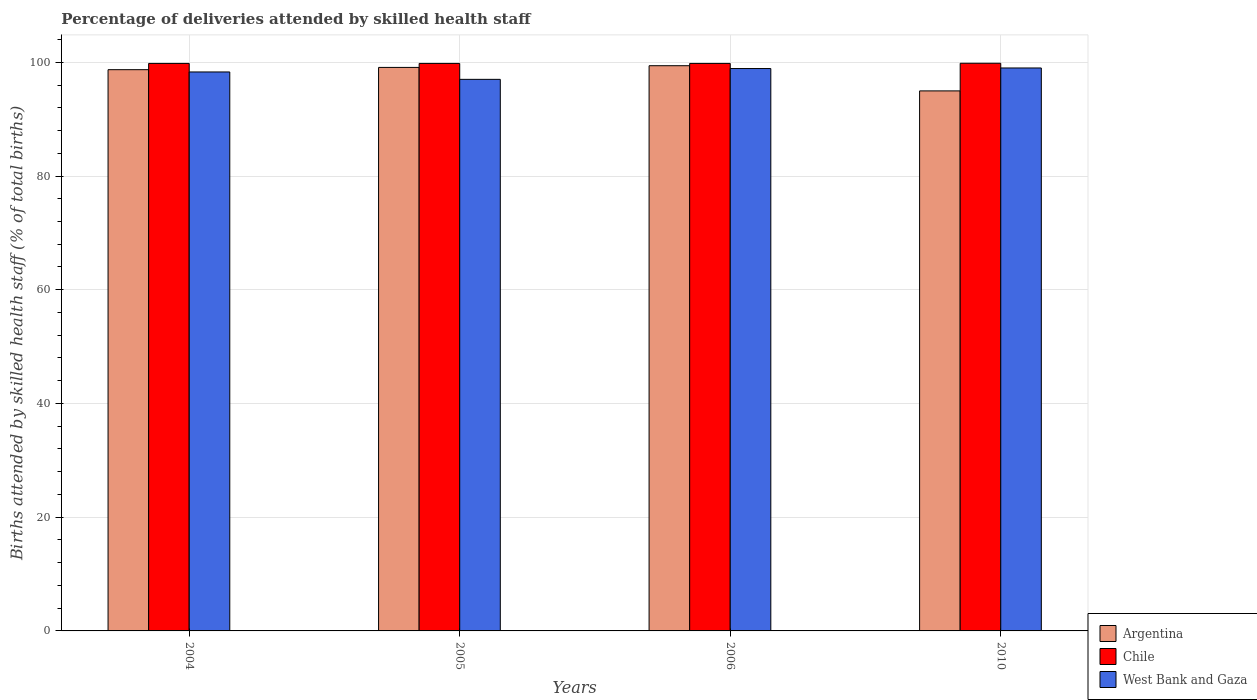How many groups of bars are there?
Your response must be concise. 4. Are the number of bars per tick equal to the number of legend labels?
Offer a terse response. Yes. How many bars are there on the 1st tick from the left?
Provide a short and direct response. 3. How many bars are there on the 4th tick from the right?
Your response must be concise. 3. What is the percentage of births attended by skilled health staff in Chile in 2004?
Give a very brief answer. 99.8. Across all years, what is the maximum percentage of births attended by skilled health staff in West Bank and Gaza?
Provide a short and direct response. 99. Across all years, what is the minimum percentage of births attended by skilled health staff in Argentina?
Offer a very short reply. 94.97. What is the total percentage of births attended by skilled health staff in Argentina in the graph?
Provide a short and direct response. 392.17. What is the difference between the percentage of births attended by skilled health staff in Argentina in 2004 and that in 2006?
Your answer should be very brief. -0.7. What is the difference between the percentage of births attended by skilled health staff in Argentina in 2005 and the percentage of births attended by skilled health staff in West Bank and Gaza in 2004?
Offer a very short reply. 0.8. What is the average percentage of births attended by skilled health staff in West Bank and Gaza per year?
Your response must be concise. 98.3. In the year 2010, what is the difference between the percentage of births attended by skilled health staff in Argentina and percentage of births attended by skilled health staff in Chile?
Offer a terse response. -4.86. In how many years, is the percentage of births attended by skilled health staff in West Bank and Gaza greater than 96 %?
Make the answer very short. 4. What is the ratio of the percentage of births attended by skilled health staff in West Bank and Gaza in 2004 to that in 2010?
Provide a succinct answer. 0.99. Is the percentage of births attended by skilled health staff in Chile in 2006 less than that in 2010?
Provide a short and direct response. Yes. Is the difference between the percentage of births attended by skilled health staff in Argentina in 2004 and 2006 greater than the difference between the percentage of births attended by skilled health staff in Chile in 2004 and 2006?
Offer a very short reply. No. What is the difference between the highest and the second highest percentage of births attended by skilled health staff in Chile?
Provide a short and direct response. 0.03. What is the difference between the highest and the lowest percentage of births attended by skilled health staff in Argentina?
Your answer should be compact. 4.43. What does the 1st bar from the right in 2006 represents?
Keep it short and to the point. West Bank and Gaza. Is it the case that in every year, the sum of the percentage of births attended by skilled health staff in Chile and percentage of births attended by skilled health staff in West Bank and Gaza is greater than the percentage of births attended by skilled health staff in Argentina?
Make the answer very short. Yes. How many bars are there?
Your answer should be very brief. 12. Are all the bars in the graph horizontal?
Your response must be concise. No. What is the difference between two consecutive major ticks on the Y-axis?
Offer a very short reply. 20. Are the values on the major ticks of Y-axis written in scientific E-notation?
Ensure brevity in your answer.  No. Does the graph contain any zero values?
Provide a succinct answer. No. Does the graph contain grids?
Offer a very short reply. Yes. Where does the legend appear in the graph?
Provide a short and direct response. Bottom right. How many legend labels are there?
Your answer should be very brief. 3. What is the title of the graph?
Offer a terse response. Percentage of deliveries attended by skilled health staff. What is the label or title of the Y-axis?
Make the answer very short. Births attended by skilled health staff (% of total births). What is the Births attended by skilled health staff (% of total births) of Argentina in 2004?
Provide a short and direct response. 98.7. What is the Births attended by skilled health staff (% of total births) of Chile in 2004?
Make the answer very short. 99.8. What is the Births attended by skilled health staff (% of total births) in West Bank and Gaza in 2004?
Ensure brevity in your answer.  98.3. What is the Births attended by skilled health staff (% of total births) in Argentina in 2005?
Offer a terse response. 99.1. What is the Births attended by skilled health staff (% of total births) in Chile in 2005?
Make the answer very short. 99.8. What is the Births attended by skilled health staff (% of total births) in West Bank and Gaza in 2005?
Your response must be concise. 97. What is the Births attended by skilled health staff (% of total births) in Argentina in 2006?
Make the answer very short. 99.4. What is the Births attended by skilled health staff (% of total births) of Chile in 2006?
Offer a terse response. 99.8. What is the Births attended by skilled health staff (% of total births) of West Bank and Gaza in 2006?
Make the answer very short. 98.9. What is the Births attended by skilled health staff (% of total births) of Argentina in 2010?
Make the answer very short. 94.97. What is the Births attended by skilled health staff (% of total births) of Chile in 2010?
Keep it short and to the point. 99.83. Across all years, what is the maximum Births attended by skilled health staff (% of total births) in Argentina?
Offer a terse response. 99.4. Across all years, what is the maximum Births attended by skilled health staff (% of total births) in Chile?
Offer a very short reply. 99.83. Across all years, what is the minimum Births attended by skilled health staff (% of total births) of Argentina?
Ensure brevity in your answer.  94.97. Across all years, what is the minimum Births attended by skilled health staff (% of total births) of Chile?
Provide a short and direct response. 99.8. Across all years, what is the minimum Births attended by skilled health staff (% of total births) in West Bank and Gaza?
Your answer should be compact. 97. What is the total Births attended by skilled health staff (% of total births) of Argentina in the graph?
Your response must be concise. 392.17. What is the total Births attended by skilled health staff (% of total births) in Chile in the graph?
Your response must be concise. 399.23. What is the total Births attended by skilled health staff (% of total births) in West Bank and Gaza in the graph?
Ensure brevity in your answer.  393.2. What is the difference between the Births attended by skilled health staff (% of total births) in Argentina in 2004 and that in 2005?
Ensure brevity in your answer.  -0.4. What is the difference between the Births attended by skilled health staff (% of total births) of Chile in 2004 and that in 2006?
Keep it short and to the point. 0. What is the difference between the Births attended by skilled health staff (% of total births) of Argentina in 2004 and that in 2010?
Your answer should be very brief. 3.73. What is the difference between the Births attended by skilled health staff (% of total births) of Chile in 2004 and that in 2010?
Make the answer very short. -0.03. What is the difference between the Births attended by skilled health staff (% of total births) in Chile in 2005 and that in 2006?
Your response must be concise. 0. What is the difference between the Births attended by skilled health staff (% of total births) in West Bank and Gaza in 2005 and that in 2006?
Ensure brevity in your answer.  -1.9. What is the difference between the Births attended by skilled health staff (% of total births) of Argentina in 2005 and that in 2010?
Your answer should be very brief. 4.13. What is the difference between the Births attended by skilled health staff (% of total births) in Chile in 2005 and that in 2010?
Give a very brief answer. -0.03. What is the difference between the Births attended by skilled health staff (% of total births) in West Bank and Gaza in 2005 and that in 2010?
Ensure brevity in your answer.  -2. What is the difference between the Births attended by skilled health staff (% of total births) of Argentina in 2006 and that in 2010?
Make the answer very short. 4.43. What is the difference between the Births attended by skilled health staff (% of total births) in Chile in 2006 and that in 2010?
Your answer should be very brief. -0.03. What is the difference between the Births attended by skilled health staff (% of total births) of West Bank and Gaza in 2006 and that in 2010?
Keep it short and to the point. -0.1. What is the difference between the Births attended by skilled health staff (% of total births) of Chile in 2004 and the Births attended by skilled health staff (% of total births) of West Bank and Gaza in 2005?
Offer a very short reply. 2.8. What is the difference between the Births attended by skilled health staff (% of total births) in Chile in 2004 and the Births attended by skilled health staff (% of total births) in West Bank and Gaza in 2006?
Your answer should be very brief. 0.9. What is the difference between the Births attended by skilled health staff (% of total births) in Argentina in 2004 and the Births attended by skilled health staff (% of total births) in Chile in 2010?
Provide a short and direct response. -1.13. What is the difference between the Births attended by skilled health staff (% of total births) of Chile in 2005 and the Births attended by skilled health staff (% of total births) of West Bank and Gaza in 2006?
Your answer should be very brief. 0.9. What is the difference between the Births attended by skilled health staff (% of total births) of Argentina in 2005 and the Births attended by skilled health staff (% of total births) of Chile in 2010?
Offer a very short reply. -0.73. What is the difference between the Births attended by skilled health staff (% of total births) in Argentina in 2005 and the Births attended by skilled health staff (% of total births) in West Bank and Gaza in 2010?
Your response must be concise. 0.1. What is the difference between the Births attended by skilled health staff (% of total births) in Chile in 2005 and the Births attended by skilled health staff (% of total births) in West Bank and Gaza in 2010?
Make the answer very short. 0.8. What is the difference between the Births attended by skilled health staff (% of total births) in Argentina in 2006 and the Births attended by skilled health staff (% of total births) in Chile in 2010?
Give a very brief answer. -0.43. What is the difference between the Births attended by skilled health staff (% of total births) in Argentina in 2006 and the Births attended by skilled health staff (% of total births) in West Bank and Gaza in 2010?
Your answer should be compact. 0.4. What is the average Births attended by skilled health staff (% of total births) of Argentina per year?
Provide a succinct answer. 98.04. What is the average Births attended by skilled health staff (% of total births) of Chile per year?
Provide a short and direct response. 99.81. What is the average Births attended by skilled health staff (% of total births) in West Bank and Gaza per year?
Your answer should be very brief. 98.3. In the year 2004, what is the difference between the Births attended by skilled health staff (% of total births) in Chile and Births attended by skilled health staff (% of total births) in West Bank and Gaza?
Give a very brief answer. 1.5. In the year 2005, what is the difference between the Births attended by skilled health staff (% of total births) in Argentina and Births attended by skilled health staff (% of total births) in West Bank and Gaza?
Offer a terse response. 2.1. In the year 2010, what is the difference between the Births attended by skilled health staff (% of total births) of Argentina and Births attended by skilled health staff (% of total births) of Chile?
Make the answer very short. -4.86. In the year 2010, what is the difference between the Births attended by skilled health staff (% of total births) in Argentina and Births attended by skilled health staff (% of total births) in West Bank and Gaza?
Offer a terse response. -4.03. In the year 2010, what is the difference between the Births attended by skilled health staff (% of total births) of Chile and Births attended by skilled health staff (% of total births) of West Bank and Gaza?
Your answer should be compact. 0.83. What is the ratio of the Births attended by skilled health staff (% of total births) in Chile in 2004 to that in 2005?
Your response must be concise. 1. What is the ratio of the Births attended by skilled health staff (% of total births) of West Bank and Gaza in 2004 to that in 2005?
Your answer should be compact. 1.01. What is the ratio of the Births attended by skilled health staff (% of total births) in Argentina in 2004 to that in 2006?
Make the answer very short. 0.99. What is the ratio of the Births attended by skilled health staff (% of total births) in Chile in 2004 to that in 2006?
Give a very brief answer. 1. What is the ratio of the Births attended by skilled health staff (% of total births) of Argentina in 2004 to that in 2010?
Provide a succinct answer. 1.04. What is the ratio of the Births attended by skilled health staff (% of total births) of Chile in 2004 to that in 2010?
Provide a succinct answer. 1. What is the ratio of the Births attended by skilled health staff (% of total births) of Argentina in 2005 to that in 2006?
Make the answer very short. 1. What is the ratio of the Births attended by skilled health staff (% of total births) of Chile in 2005 to that in 2006?
Provide a succinct answer. 1. What is the ratio of the Births attended by skilled health staff (% of total births) of West Bank and Gaza in 2005 to that in 2006?
Your answer should be compact. 0.98. What is the ratio of the Births attended by skilled health staff (% of total births) of Argentina in 2005 to that in 2010?
Make the answer very short. 1.04. What is the ratio of the Births attended by skilled health staff (% of total births) of West Bank and Gaza in 2005 to that in 2010?
Make the answer very short. 0.98. What is the ratio of the Births attended by skilled health staff (% of total births) in Argentina in 2006 to that in 2010?
Make the answer very short. 1.05. What is the difference between the highest and the second highest Births attended by skilled health staff (% of total births) of West Bank and Gaza?
Your answer should be very brief. 0.1. What is the difference between the highest and the lowest Births attended by skilled health staff (% of total births) in Argentina?
Offer a terse response. 4.43. 